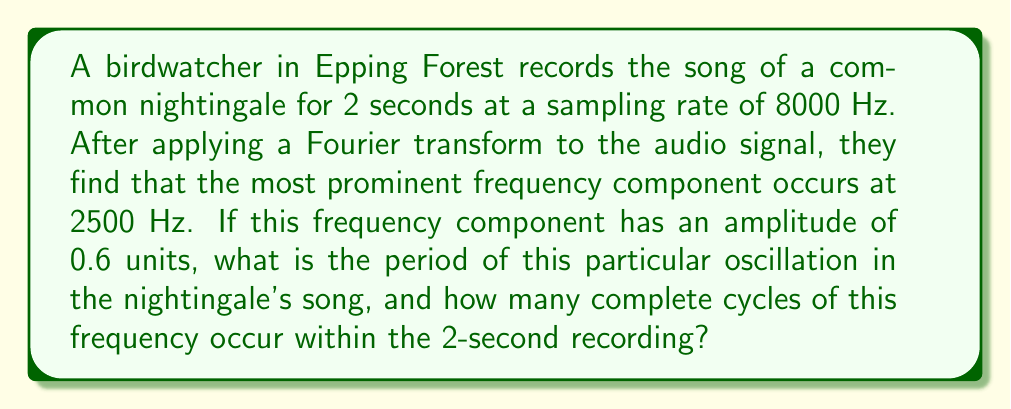Give your solution to this math problem. To solve this problem, we need to follow these steps:

1. Calculate the period of the 2500 Hz frequency component:
   The period (T) is the inverse of the frequency (f).
   $$T = \frac{1}{f} = \frac{1}{2500 \text{ Hz}} = 0.0004 \text{ seconds}$$

2. Calculate the number of complete cycles in the 2-second recording:
   The number of cycles (N) is the total time (t) divided by the period (T).
   $$N = \frac{t}{T} = \frac{2 \text{ seconds}}{0.0004 \text{ seconds}} = 5000 \text{ cycles}$$

Note: The amplitude of 0.6 units doesn't affect the calculations for period or number of cycles, but it indicates the relative strength of this frequency component in the overall spectrum of the birdsong.

The Fourier transform has allowed us to identify this prominent frequency in the nightingale's song, which could be characteristic of its species or a particular type of call. This analysis can be useful for bird identification and studying communication patterns in the quiet forest environment.
Answer: The period of the 2500 Hz oscillation in the nightingale's song is 0.0004 seconds, and 5000 complete cycles of this frequency occur within the 2-second recording. 